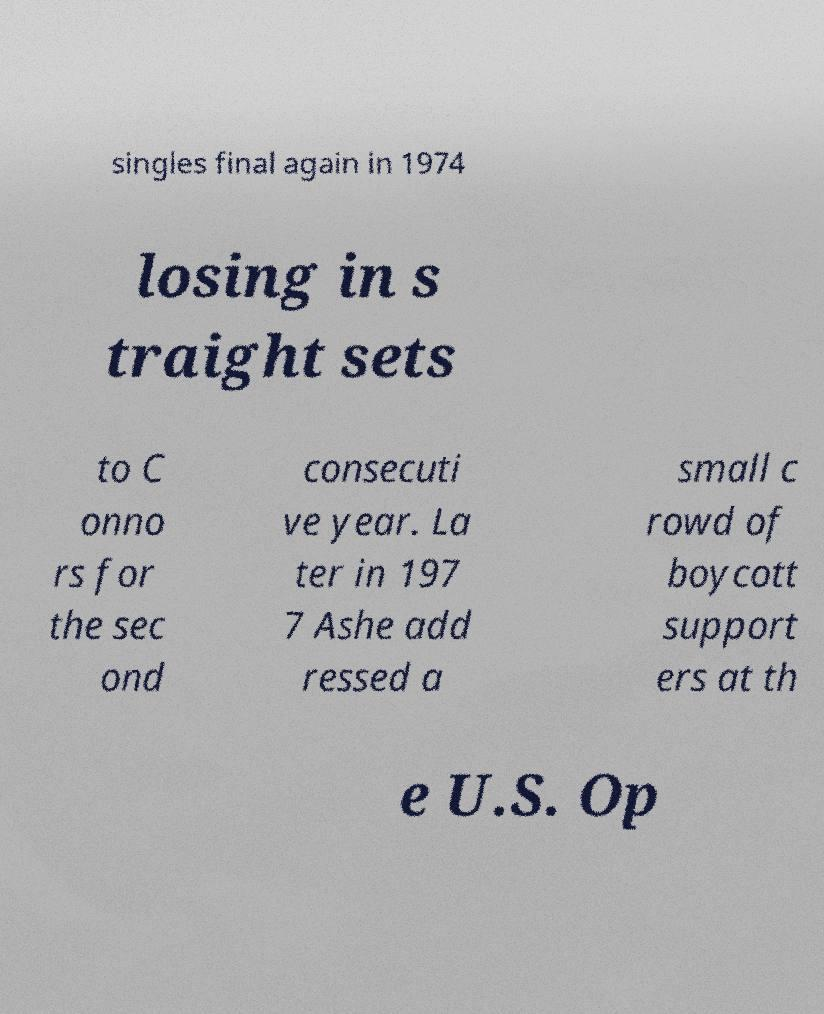Could you extract and type out the text from this image? singles final again in 1974 losing in s traight sets to C onno rs for the sec ond consecuti ve year. La ter in 197 7 Ashe add ressed a small c rowd of boycott support ers at th e U.S. Op 